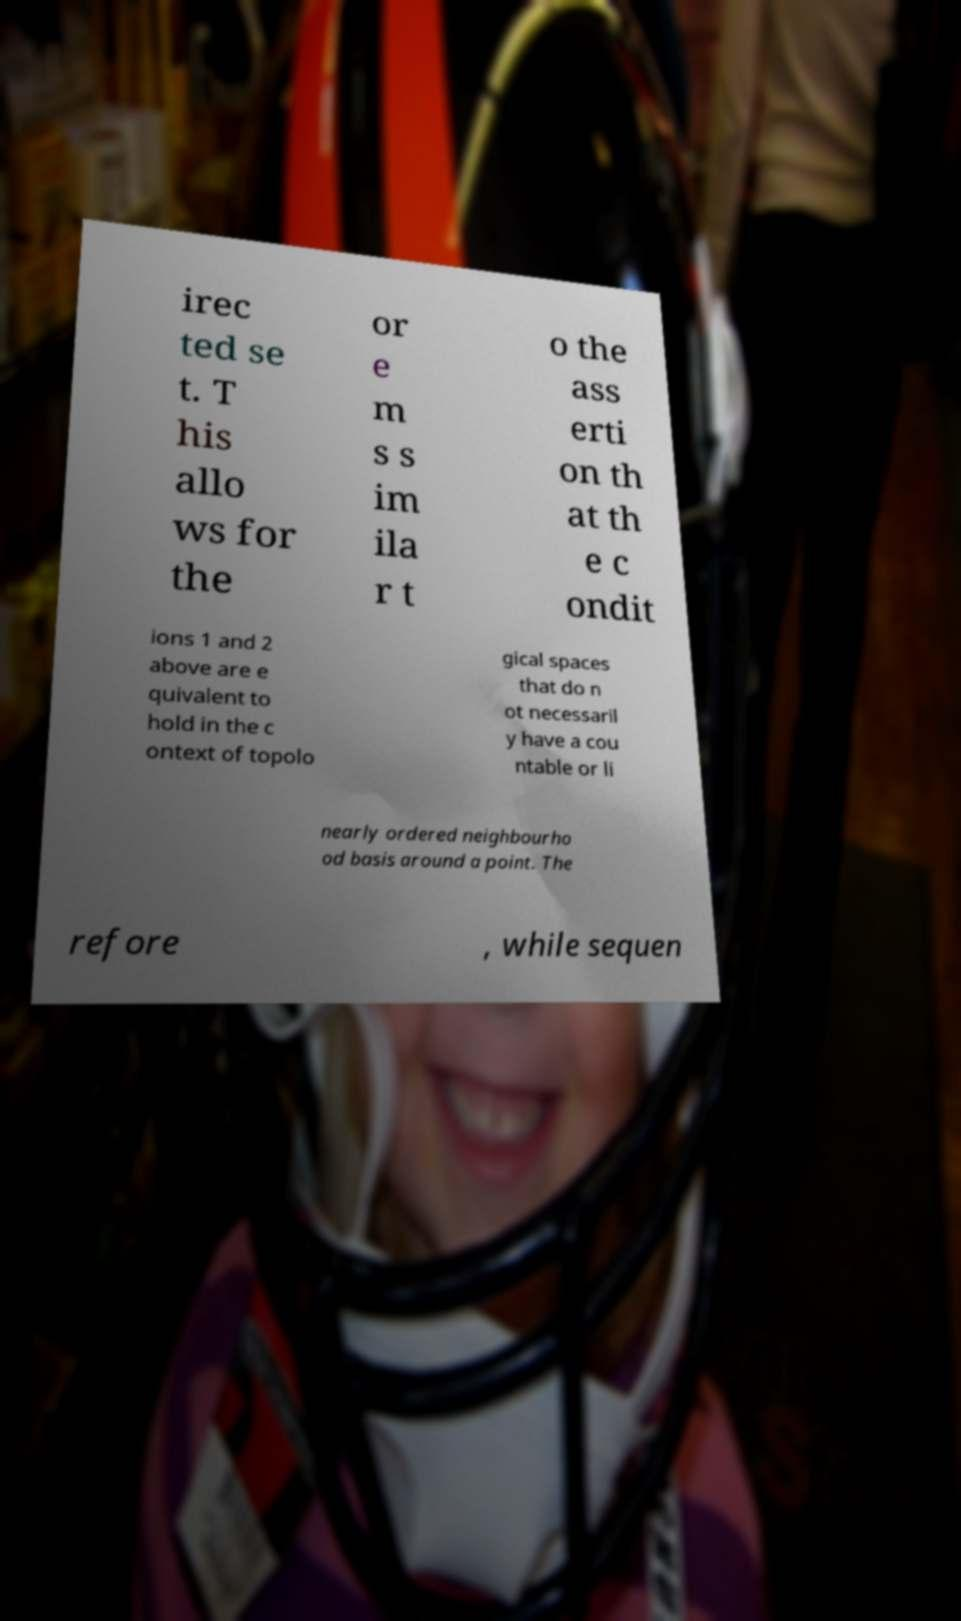Could you extract and type out the text from this image? irec ted se t. T his allo ws for the or e m s s im ila r t o the ass erti on th at th e c ondit ions 1 and 2 above are e quivalent to hold in the c ontext of topolo gical spaces that do n ot necessaril y have a cou ntable or li nearly ordered neighbourho od basis around a point. The refore , while sequen 